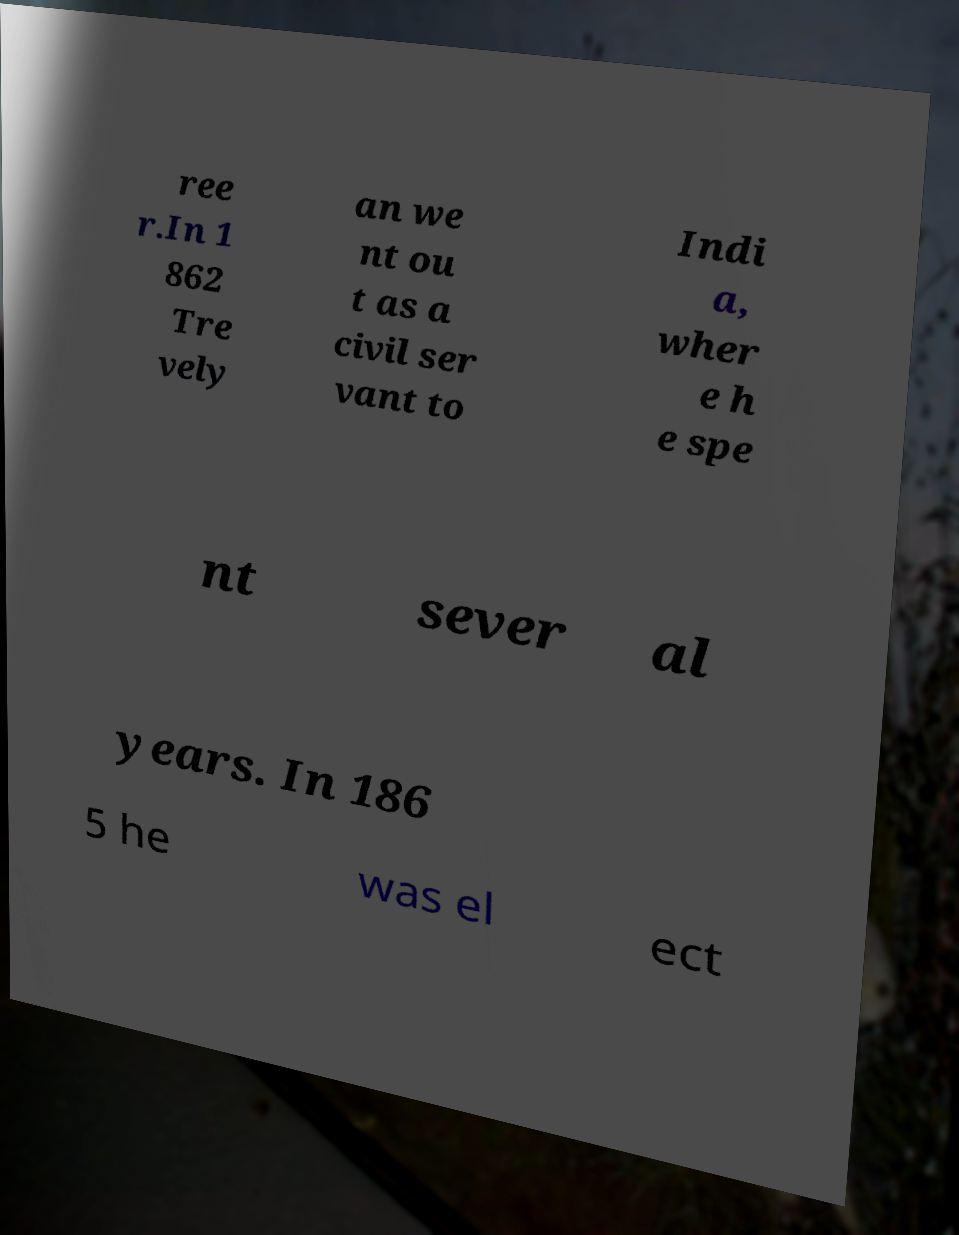What messages or text are displayed in this image? I need them in a readable, typed format. ree r.In 1 862 Tre vely an we nt ou t as a civil ser vant to Indi a, wher e h e spe nt sever al years. In 186 5 he was el ect 